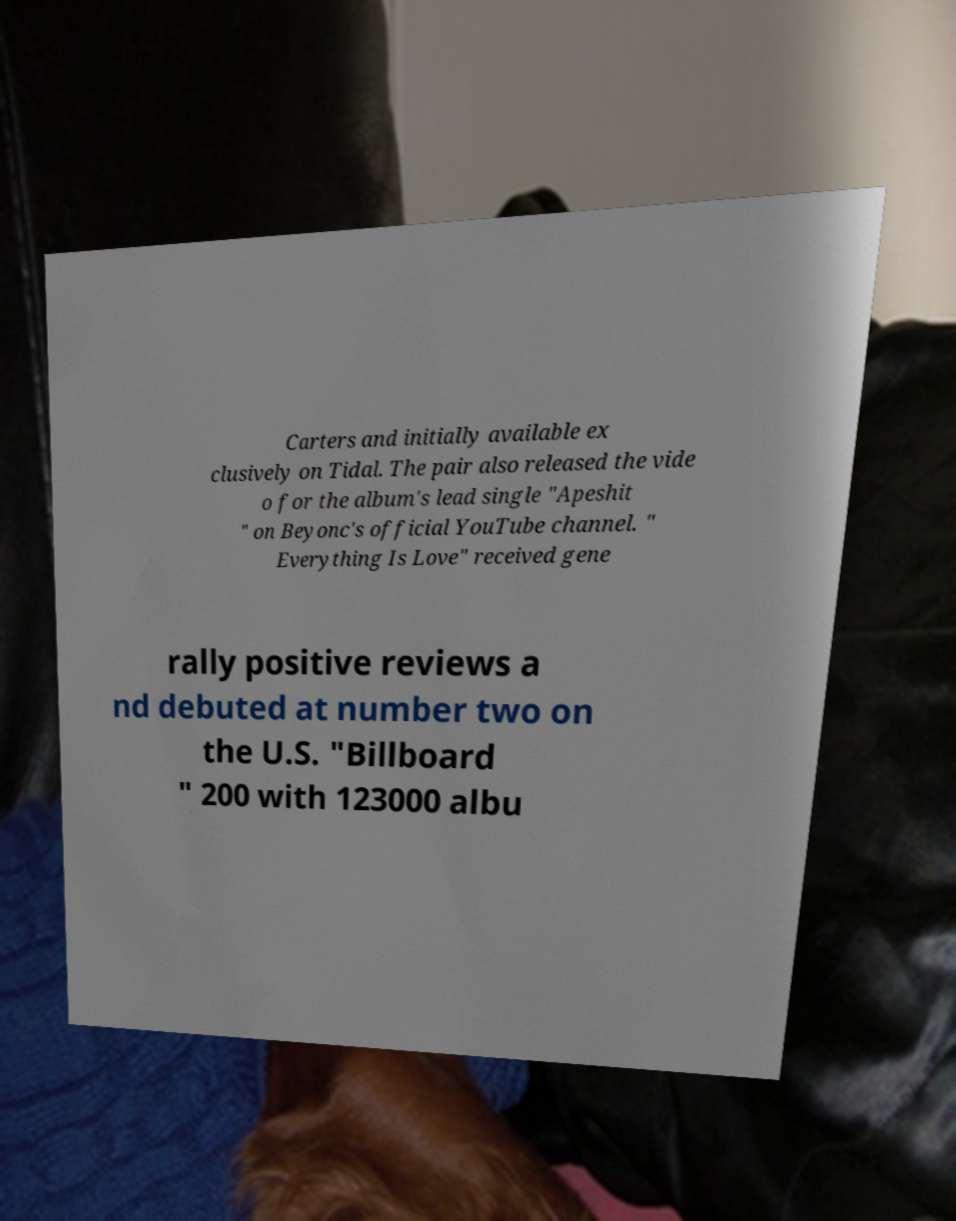What messages or text are displayed in this image? I need them in a readable, typed format. Carters and initially available ex clusively on Tidal. The pair also released the vide o for the album's lead single "Apeshit " on Beyonc's official YouTube channel. " Everything Is Love" received gene rally positive reviews a nd debuted at number two on the U.S. "Billboard " 200 with 123000 albu 